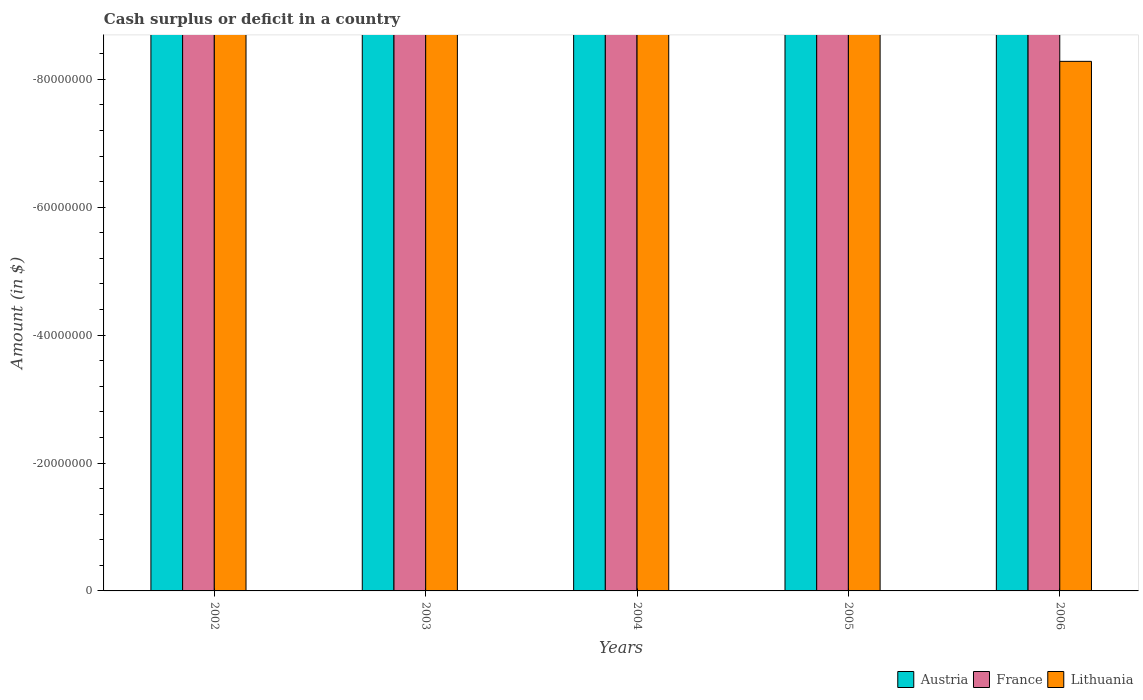Are the number of bars per tick equal to the number of legend labels?
Offer a terse response. No. Are the number of bars on each tick of the X-axis equal?
Offer a very short reply. Yes. How many bars are there on the 5th tick from the right?
Make the answer very short. 0. What is the label of the 1st group of bars from the left?
Your answer should be compact. 2002. In how many cases, is the number of bars for a given year not equal to the number of legend labels?
Provide a short and direct response. 5. What is the average amount of cash surplus or deficit in Austria per year?
Make the answer very short. 0. In how many years, is the amount of cash surplus or deficit in Lithuania greater than the average amount of cash surplus or deficit in Lithuania taken over all years?
Your answer should be compact. 0. Is it the case that in every year, the sum of the amount of cash surplus or deficit in Lithuania and amount of cash surplus or deficit in France is greater than the amount of cash surplus or deficit in Austria?
Offer a very short reply. No. Are all the bars in the graph horizontal?
Provide a short and direct response. No. What is the difference between two consecutive major ticks on the Y-axis?
Keep it short and to the point. 2.00e+07. Are the values on the major ticks of Y-axis written in scientific E-notation?
Your answer should be very brief. No. Does the graph contain grids?
Your response must be concise. No. Where does the legend appear in the graph?
Your answer should be compact. Bottom right. How are the legend labels stacked?
Your answer should be very brief. Horizontal. What is the title of the graph?
Your answer should be compact. Cash surplus or deficit in a country. Does "Latvia" appear as one of the legend labels in the graph?
Your answer should be compact. No. What is the label or title of the Y-axis?
Your response must be concise. Amount (in $). What is the Amount (in $) of Austria in 2002?
Provide a short and direct response. 0. What is the Amount (in $) in Lithuania in 2003?
Your answer should be very brief. 0. What is the Amount (in $) in Austria in 2004?
Make the answer very short. 0. What is the Amount (in $) of France in 2004?
Offer a very short reply. 0. What is the Amount (in $) in Austria in 2005?
Give a very brief answer. 0. What is the Amount (in $) in France in 2005?
Provide a succinct answer. 0. What is the Amount (in $) of Lithuania in 2005?
Offer a terse response. 0. What is the total Amount (in $) in Austria in the graph?
Offer a very short reply. 0. What is the total Amount (in $) of France in the graph?
Your answer should be compact. 0. What is the total Amount (in $) in Lithuania in the graph?
Give a very brief answer. 0. 